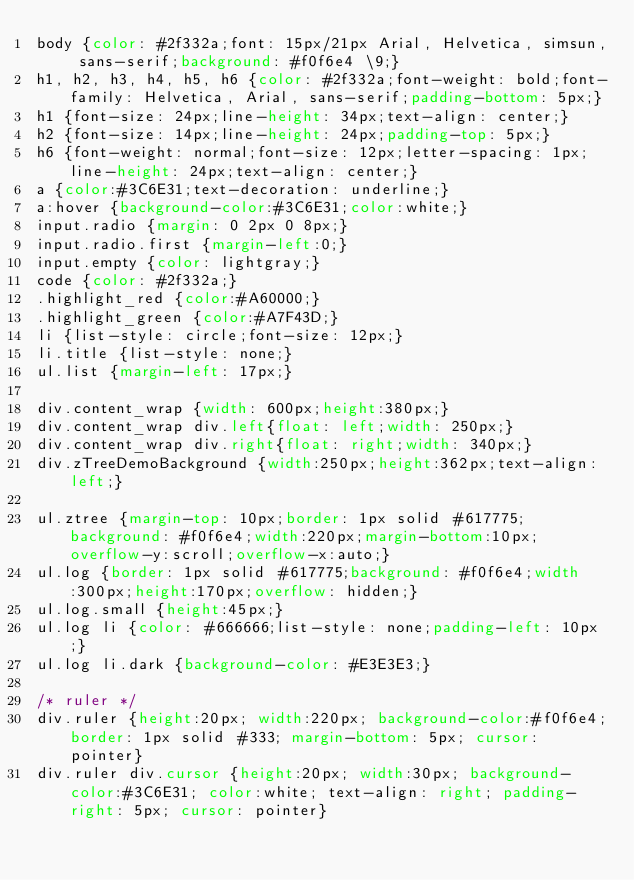<code> <loc_0><loc_0><loc_500><loc_500><_CSS_>body {color: #2f332a;font: 15px/21px Arial, Helvetica, simsun, sans-serif;background: #f0f6e4 \9;}
h1, h2, h3, h4, h5, h6 {color: #2f332a;font-weight: bold;font-family: Helvetica, Arial, sans-serif;padding-bottom: 5px;}
h1 {font-size: 24px;line-height: 34px;text-align: center;}
h2 {font-size: 14px;line-height: 24px;padding-top: 5px;}
h6 {font-weight: normal;font-size: 12px;letter-spacing: 1px;line-height: 24px;text-align: center;}
a {color:#3C6E31;text-decoration: underline;}
a:hover {background-color:#3C6E31;color:white;}
input.radio {margin: 0 2px 0 8px;}
input.radio.first {margin-left:0;}
input.empty {color: lightgray;}
code {color: #2f332a;}
.highlight_red {color:#A60000;}
.highlight_green {color:#A7F43D;}
li {list-style: circle;font-size: 12px;}
li.title {list-style: none;}
ul.list {margin-left: 17px;}

div.content_wrap {width: 600px;height:380px;}
div.content_wrap div.left{float: left;width: 250px;}
div.content_wrap div.right{float: right;width: 340px;}
div.zTreeDemoBackground {width:250px;height:362px;text-align:left;}

ul.ztree {margin-top: 10px;border: 1px solid #617775;background: #f0f6e4;width:220px;margin-bottom:10px;overflow-y:scroll;overflow-x:auto;}
ul.log {border: 1px solid #617775;background: #f0f6e4;width:300px;height:170px;overflow: hidden;}
ul.log.small {height:45px;}
ul.log li {color: #666666;list-style: none;padding-left: 10px;}
ul.log li.dark {background-color: #E3E3E3;}

/* ruler */
div.ruler {height:20px; width:220px; background-color:#f0f6e4;border: 1px solid #333; margin-bottom: 5px; cursor: pointer}
div.ruler div.cursor {height:20px; width:30px; background-color:#3C6E31; color:white; text-align: right; padding-right: 5px; cursor: pointer}</code> 